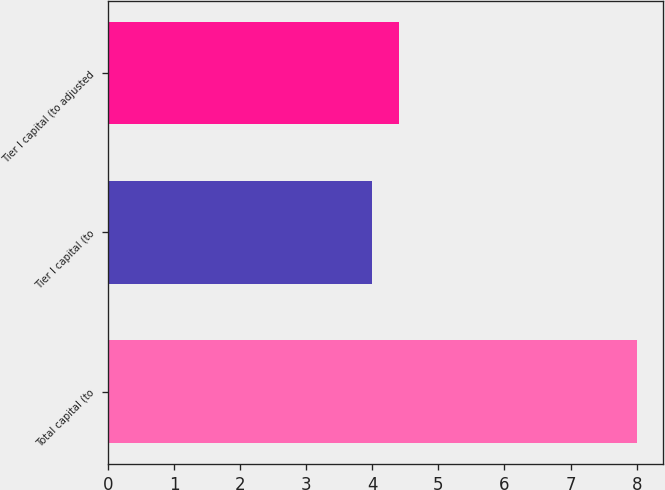<chart> <loc_0><loc_0><loc_500><loc_500><bar_chart><fcel>Total capital (to<fcel>Tier I capital (to<fcel>Tier I capital (to adjusted<nl><fcel>8<fcel>4<fcel>4.4<nl></chart> 